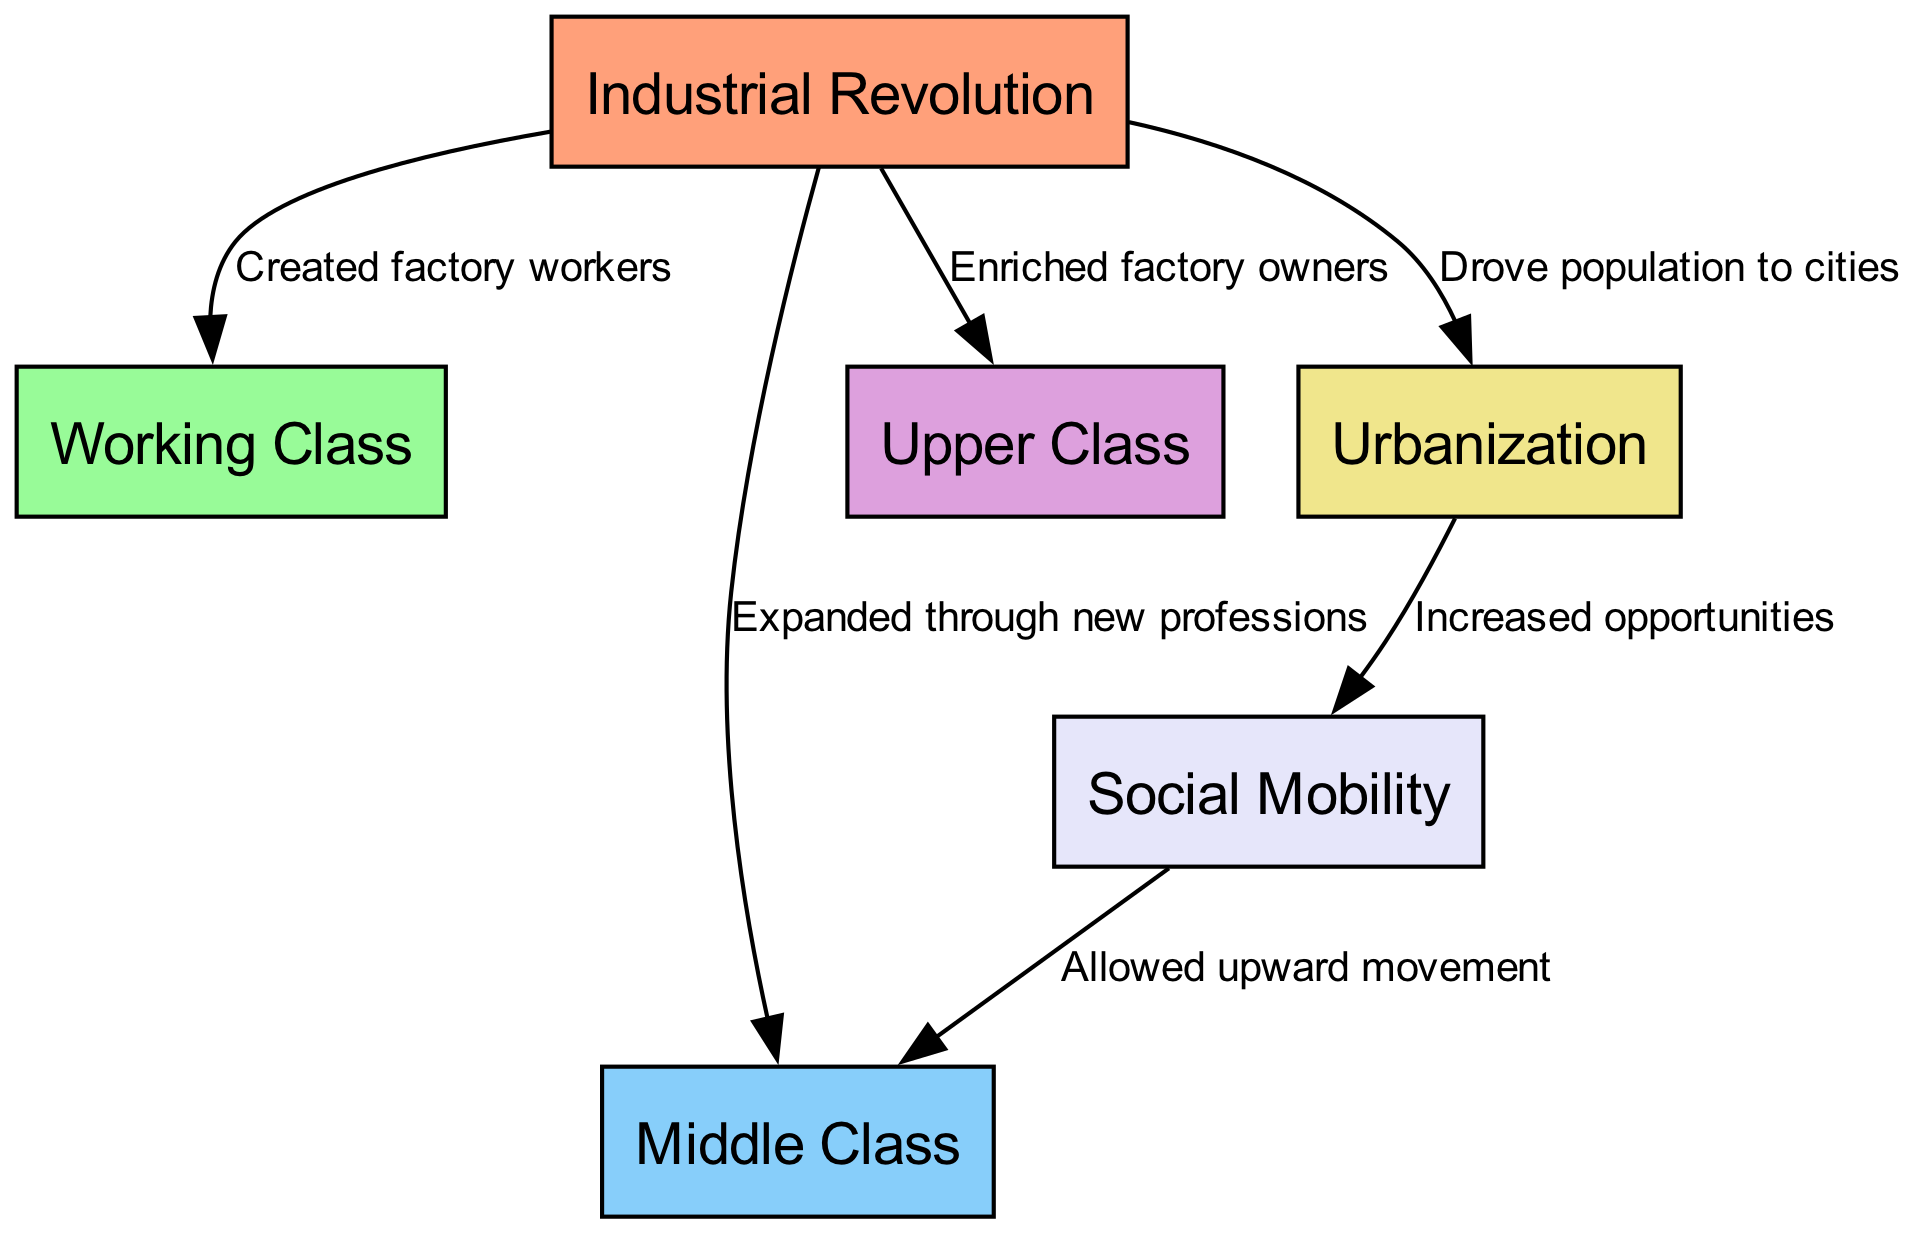What nodes are present in the diagram? The diagram contains six nodes: Industrial Revolution, Working Class, Middle Class, Upper Class, Urbanization, and Social Mobility. I identified these nodes by reviewing the 'nodes' section in the provided data where they are explicitly listed.
Answer: Industrial Revolution, Working Class, Middle Class, Upper Class, Urbanization, Social Mobility How many edges are there in total? The diagram consists of six edges connecting the nodes. These edges are found in the 'edges' section of the data where each relationship is defined. Counting each entry shows there are six edges.
Answer: 6 What is the relationship between Industrial Revolution and Urbanization? The relationship is characterized as "Drove population to cities," indicating that industrialization led to urban population growth. This is a direct observation from the edge description between the two nodes in the diagram.
Answer: Drove population to cities What impact did Urbanization have on Social Mobility? Urbanization "Increased opportunities," facilitating greater social mobility as shown by the connection between Urbanization and Social Mobility in the diagram. This demonstrates how urban environments can create conditions that improve the chances for individuals to rise in social class.
Answer: Increased opportunities How did Industrial Revolution affect the Upper Class? The Industrial Revolution "Enriched factory owners," indicating that those who owned factories during this period experienced increased wealth. This is visible in the diagram through the directed edge from Industrial Revolution to Upper Class with this specific label.
Answer: Enriched factory owners What allowed upward movement in the Middle Class? Upward movement in the Middle Class was allowed by "Social Mobility," highlighting that the conditions present enabled individuals from lower classes to move up. This connection between Social Mobility and the Middle Class is illustrated in the diagram.
Answer: Allowed upward movement 